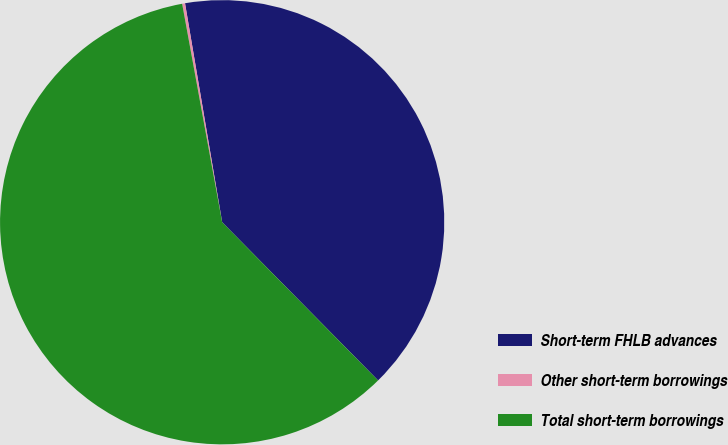Convert chart to OTSL. <chart><loc_0><loc_0><loc_500><loc_500><pie_chart><fcel>Short-term FHLB advances<fcel>Other short-term borrowings<fcel>Total short-term borrowings<nl><fcel>40.29%<fcel>0.21%<fcel>59.5%<nl></chart> 